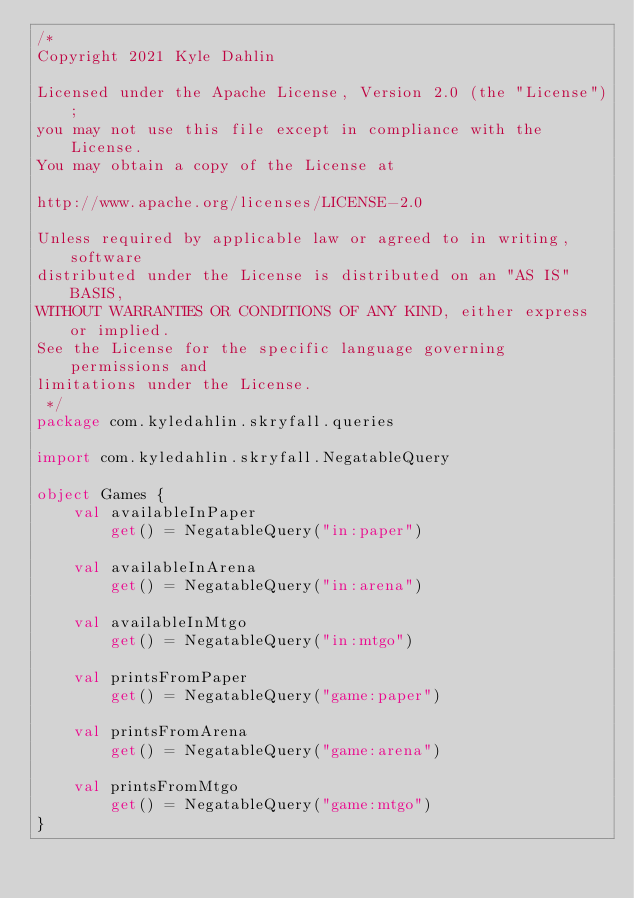<code> <loc_0><loc_0><loc_500><loc_500><_Kotlin_>/*
Copyright 2021 Kyle Dahlin

Licensed under the Apache License, Version 2.0 (the "License");
you may not use this file except in compliance with the License.
You may obtain a copy of the License at

http://www.apache.org/licenses/LICENSE-2.0

Unless required by applicable law or agreed to in writing, software
distributed under the License is distributed on an "AS IS" BASIS,
WITHOUT WARRANTIES OR CONDITIONS OF ANY KIND, either express or implied.
See the License for the specific language governing permissions and
limitations under the License.
 */
package com.kyledahlin.skryfall.queries

import com.kyledahlin.skryfall.NegatableQuery

object Games {
    val availableInPaper
        get() = NegatableQuery("in:paper")

    val availableInArena
        get() = NegatableQuery("in:arena")

    val availableInMtgo
        get() = NegatableQuery("in:mtgo")

    val printsFromPaper
        get() = NegatableQuery("game:paper")

    val printsFromArena
        get() = NegatableQuery("game:arena")

    val printsFromMtgo
        get() = NegatableQuery("game:mtgo")
}
</code> 